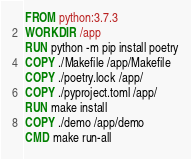Convert code to text. <code><loc_0><loc_0><loc_500><loc_500><_Dockerfile_>FROM python:3.7.3
WORKDIR /app
RUN python -m pip install poetry
COPY ./Makefile /app/Makefile
COPY ./poetry.lock /app/
COPY ./pyproject.toml /app/
RUN make install
COPY ./demo /app/demo
CMD make run-all
</code> 